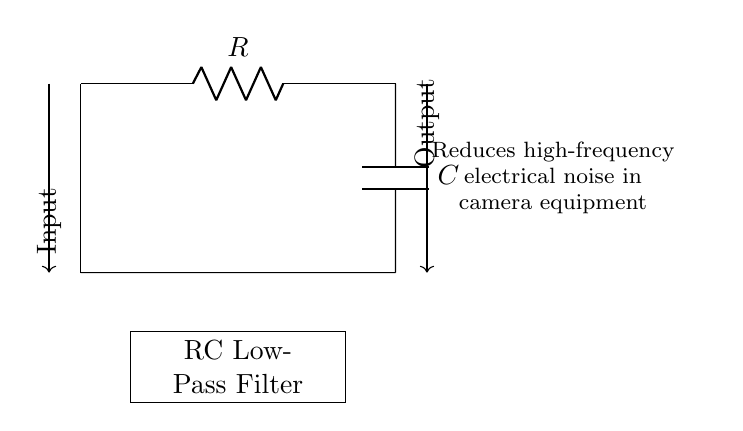What is the primary function of this circuit? The circuit is an RC low-pass filter which is designed specifically to reduce high-frequency electrical noise. This is indicated by the labeling in the diagram and its typical application in electronic circuits.
Answer: Low-pass filter What components are present in the circuit? The circuit consists of a resistor and a capacitor, as identified by the symbols labeled R and C respectively. This is typical for an RC filter circuit.
Answer: Resistor and capacitor What is the type of connection between the components? The resistor and capacitor are connected in series, as evidenced by the drawing where the output of the resistor feeds into the capacitor without any branching.
Answer: Series connection What type of filter is represented here? This is a low-pass filter, which allows signals with a frequency lower than a certain cutoff frequency to pass through while attenuating higher frequencies. This designation is confirmed by the diagram's labeling.
Answer: Low-pass What happens to high-frequency noise in this circuit? High-frequency noise is attenuated or reduced by this circuit due to the characteristics of the RC filter design, which effectively prevents high-frequency signals from passing through while allowing lower frequencies.
Answer: Attenuated What is the voltage rating of the input and output connections? The circuit does not specify an actual voltage rating; typically, it would depend on the specific components used and their ratings. However, as shown in the diagram, the voltage values are left unspecified.
Answer: Not specified 